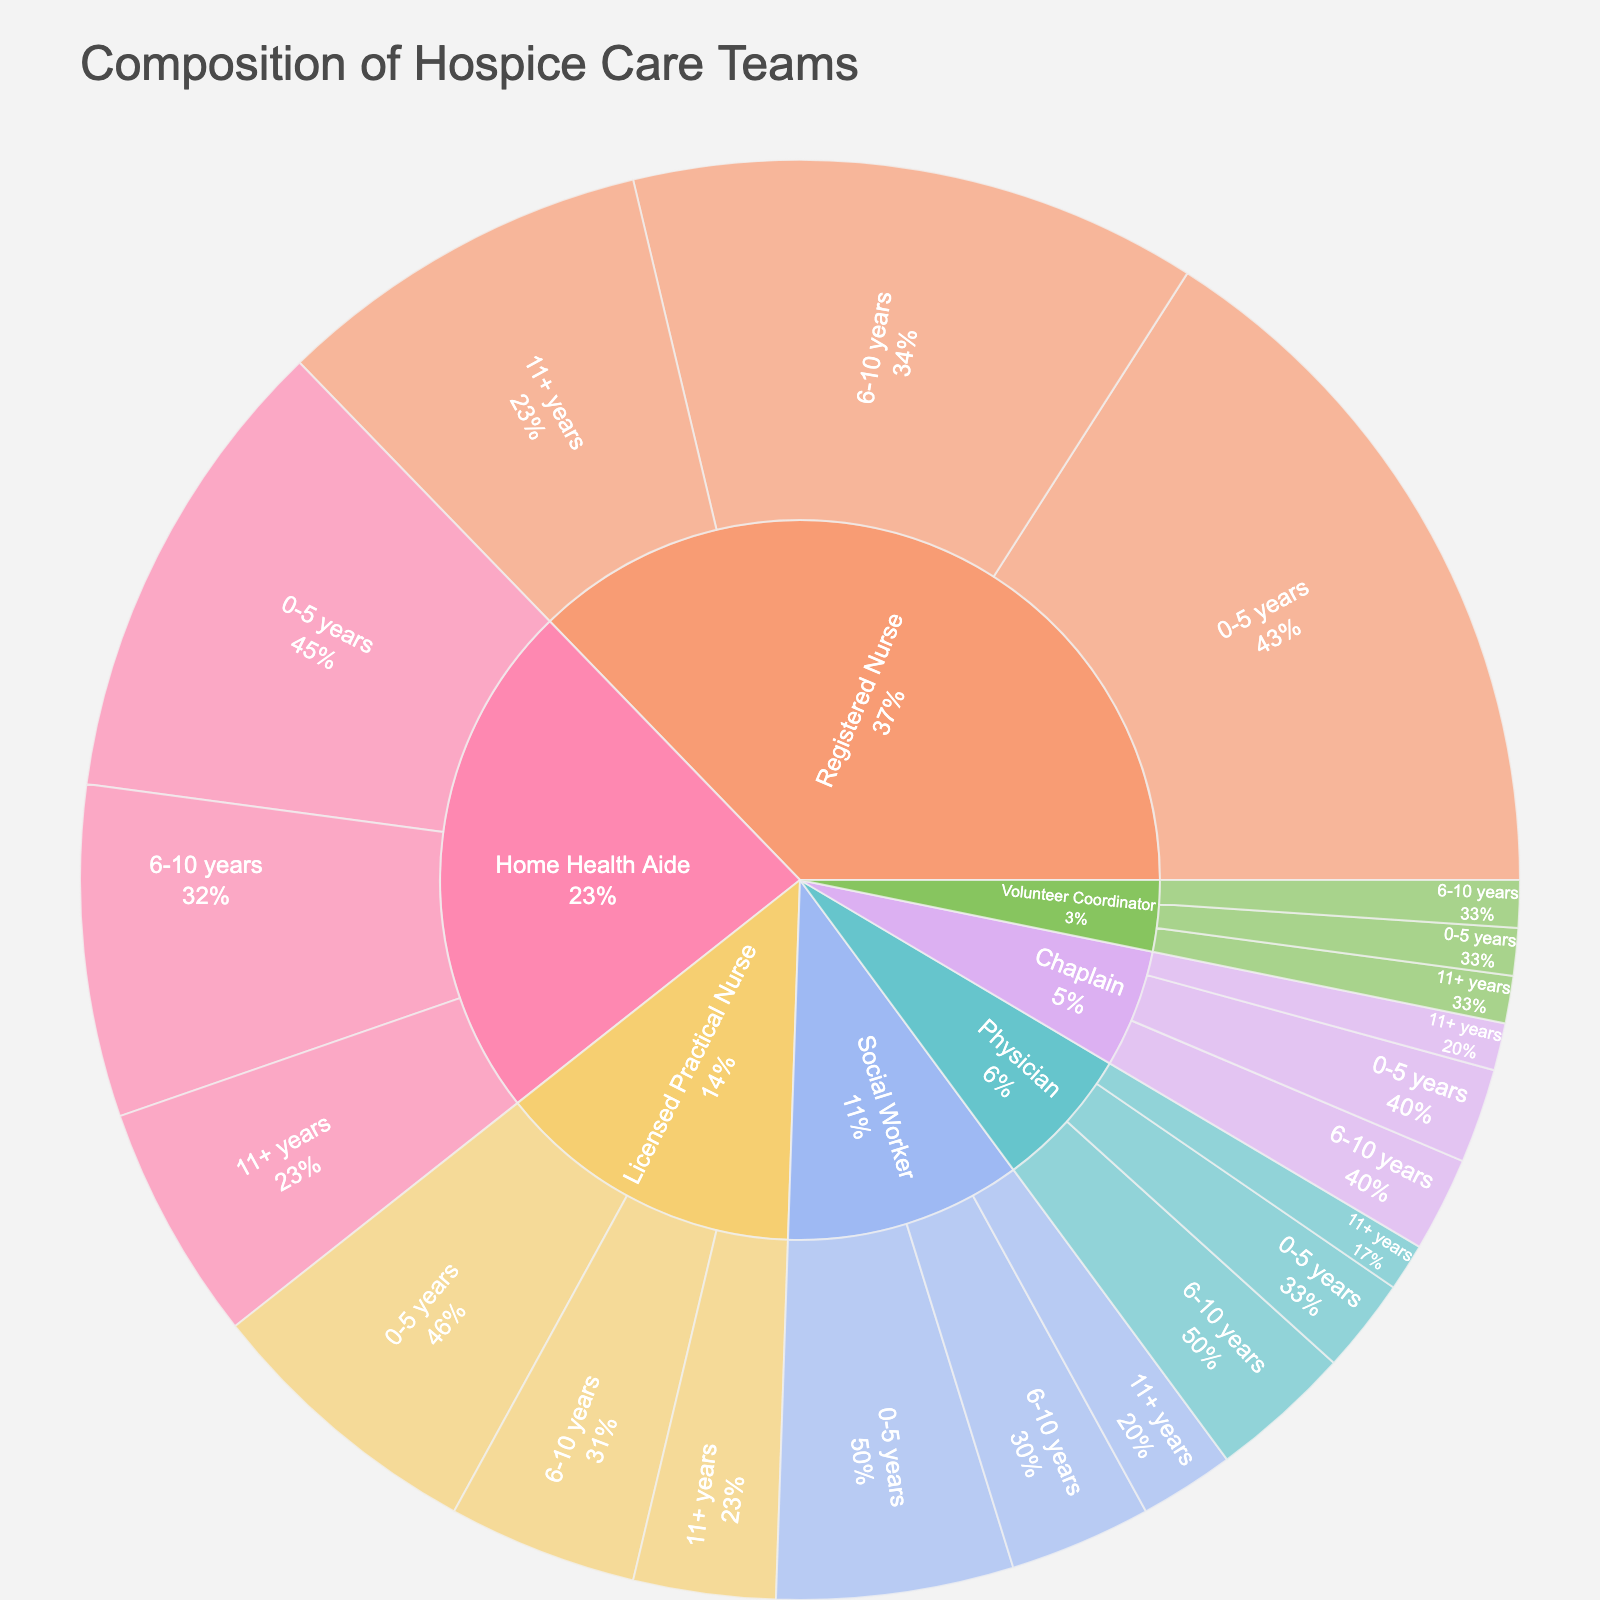what's the title of the figure? The title of the figure is written at the top and usually provides a brief description of what the chart represents.
Answer: Composition of Hospice Care Teams How many roles are represented in the figure? To find out, count the number of unique segments in the outermost layer corresponding to different professional roles.
Answer: 7 Which role has the highest count for 0-5 years of experience? Check the segments for each role with 0-5 years experience and compare their sizes/values.
Answer: Registered Nurse What's the total count of Home Health Aides across all years of experience? Sum the counts for Home Health Aides in 0-5 years (10), 6-10 years (7), and 11+ years (5).
Answer: 22 Are there more Registered Nurses with 6-10 years of experience or Home Health Aides with the same experience? Compare the counts for Registered Nurses (12) and Home Health Aides (7) within the 6-10 years segment.
Answer: Registered Nurses Which role has the least representation in the figure, and how many people does it include? Locate the smallest segment and identify its role, then check the corresponding count.
Answer: Volunteer Coordinator, 3 How does the count of Licensed Practical Nurses with 0-5 years compare to those with 11+ years of experience? Compare the counts for Licensed Practical Nurses within the 0-5 years (6) and 11+ years (3) segments.
Answer: More with 0-5 years What's the total number of people in the hospice care team with 0-5 years of experience? Sum the counts for all roles within the 0-5 years segment: 15(RN) + 6(LPN) + 5(SW) + 2(C) + 10(HHA) + 2(P) + 1(VC).
Answer: 41 What is the percentage share of Registered Nurses in the total team composition? Add the counts of all Registered Nurses (15 + 12 + 8 = 35) and divide by the total sum of all counts, then multiply by 100. Total count = 90. Percentage = (35/90) * 100.
Answer: ~38.9% Which role has the highest percentage of people with 11+ years of experience in its group? Compare the inner circle segments and see the larger slice relative to its parent segment in the 11+ years group.
Answer: Social Worker 